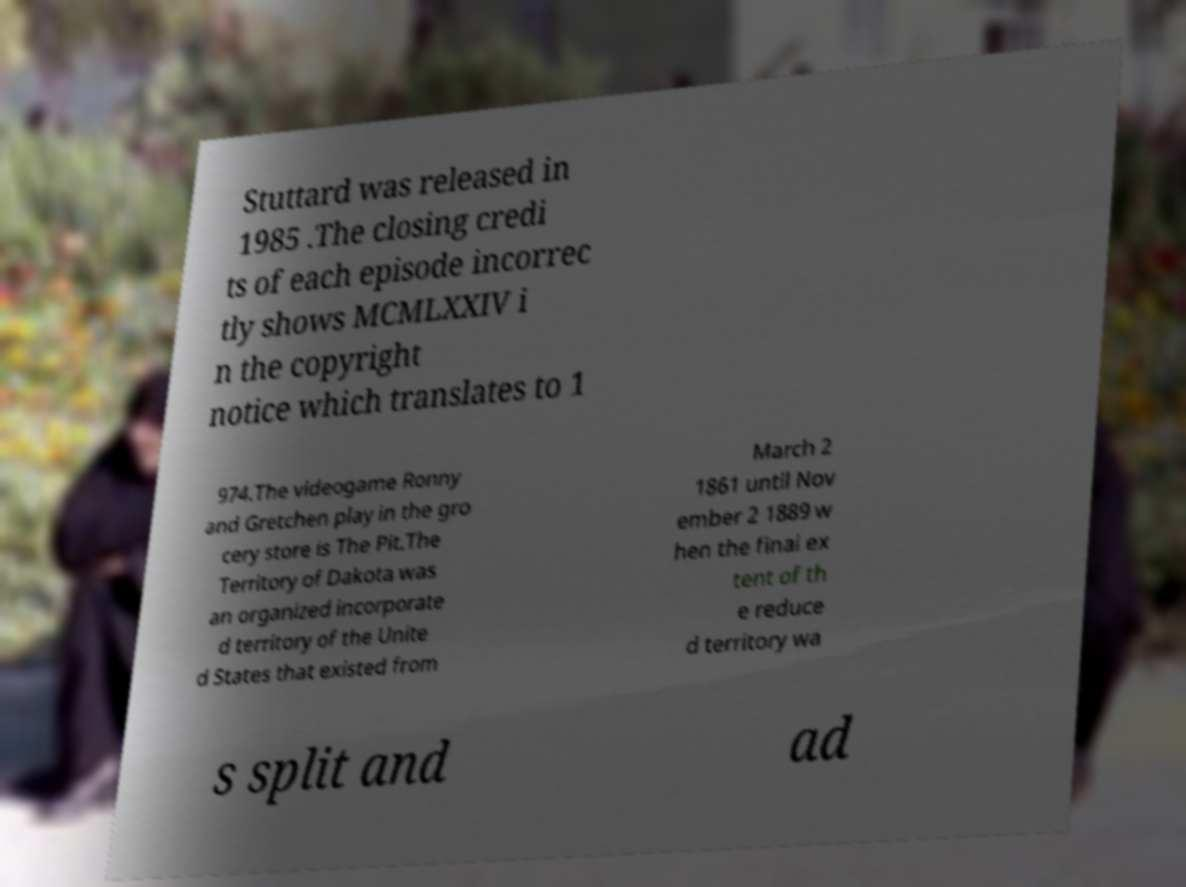Could you assist in decoding the text presented in this image and type it out clearly? Stuttard was released in 1985 .The closing credi ts of each episode incorrec tly shows MCMLXXIV i n the copyright notice which translates to 1 974.The videogame Ronny and Gretchen play in the gro cery store is The Pit.The Territory of Dakota was an organized incorporate d territory of the Unite d States that existed from March 2 1861 until Nov ember 2 1889 w hen the final ex tent of th e reduce d territory wa s split and ad 